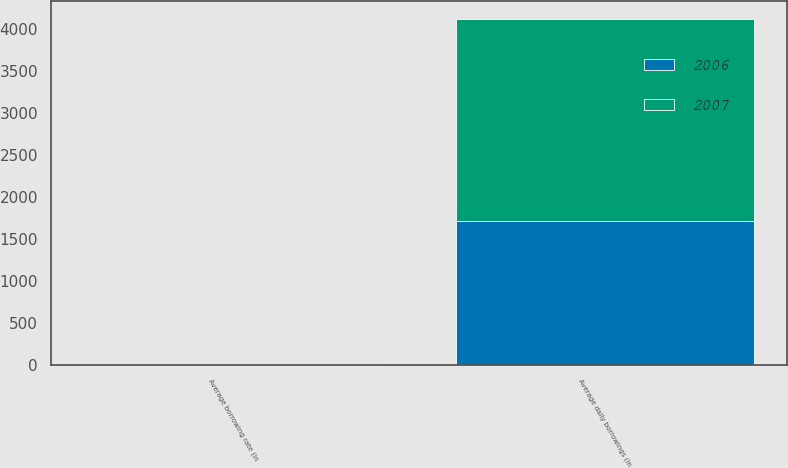<chart> <loc_0><loc_0><loc_500><loc_500><stacked_bar_chart><ecel><fcel>Average daily borrowings (in<fcel>Average borrowing rate (in<nl><fcel>2007<fcel>2408<fcel>6.2<nl><fcel>2006<fcel>1711<fcel>5.9<nl></chart> 